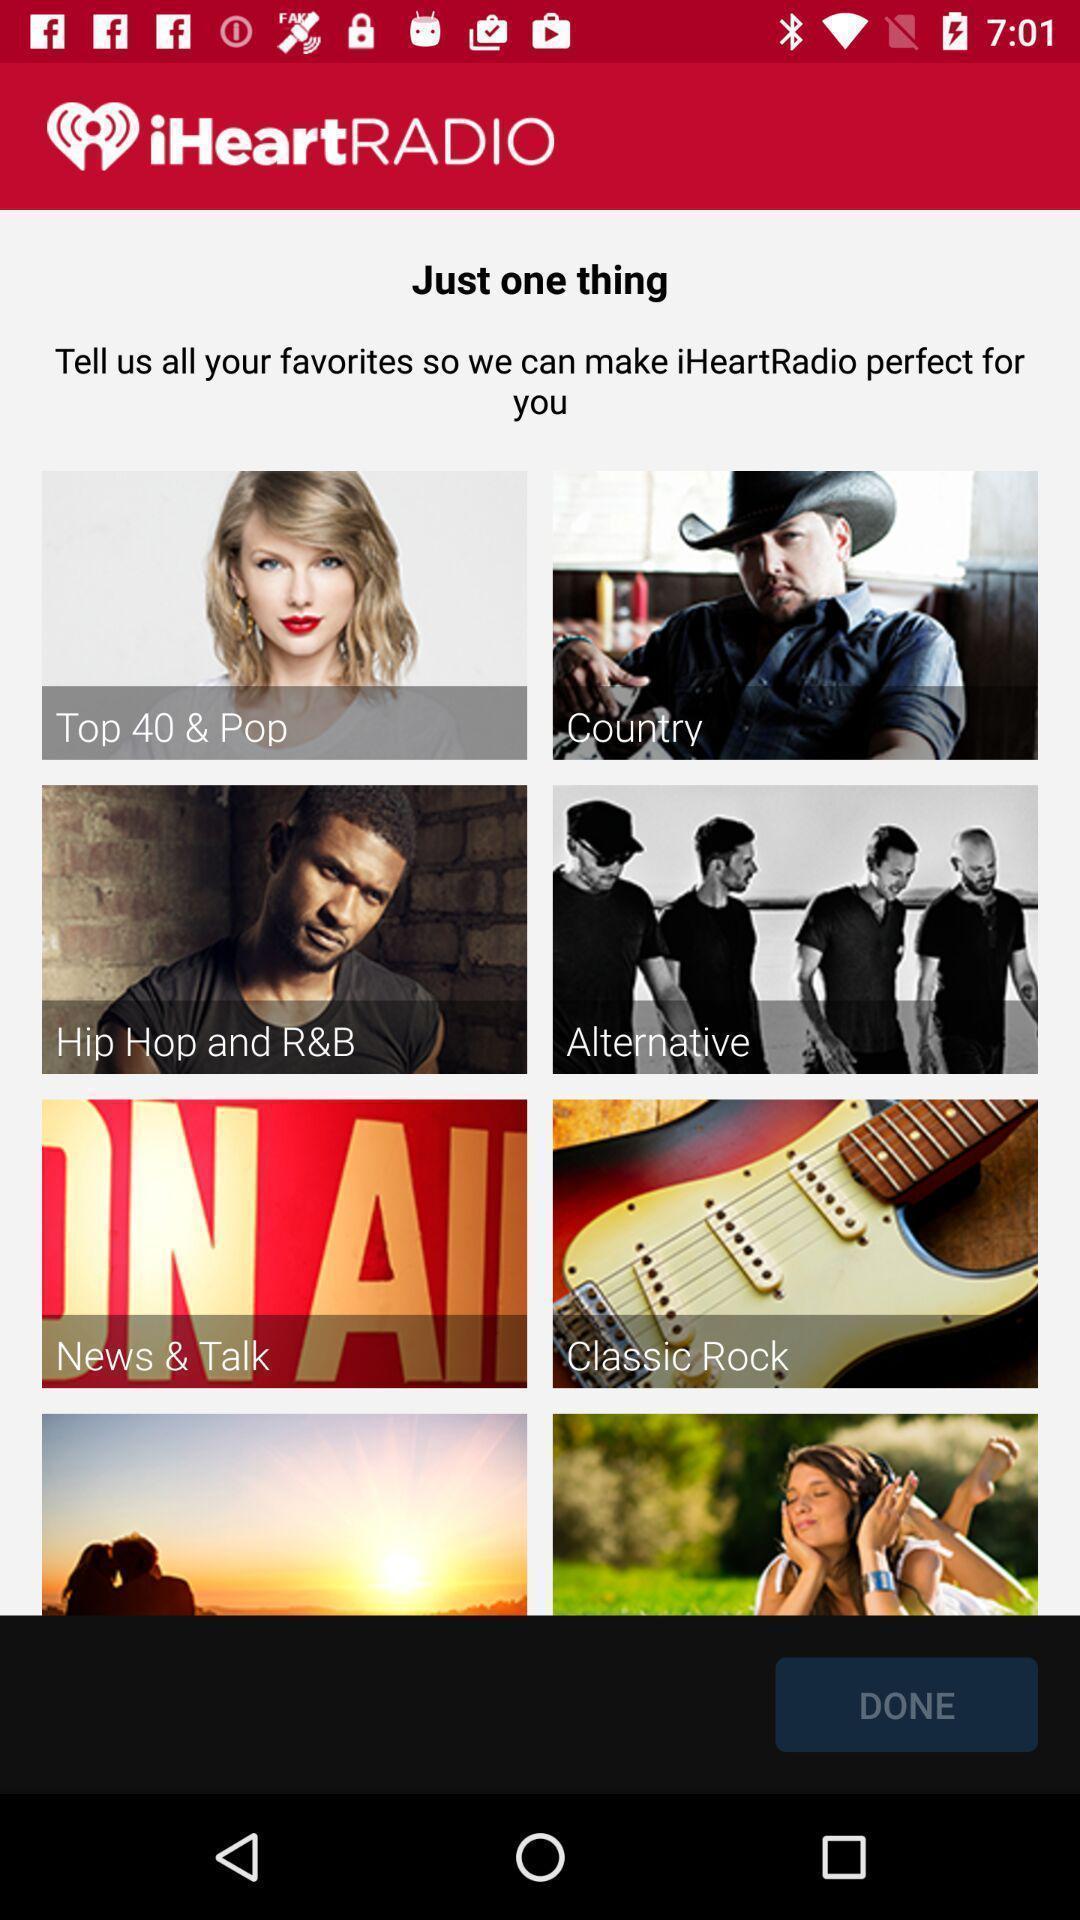What details can you identify in this image? Screen showing list of various radio stations. 